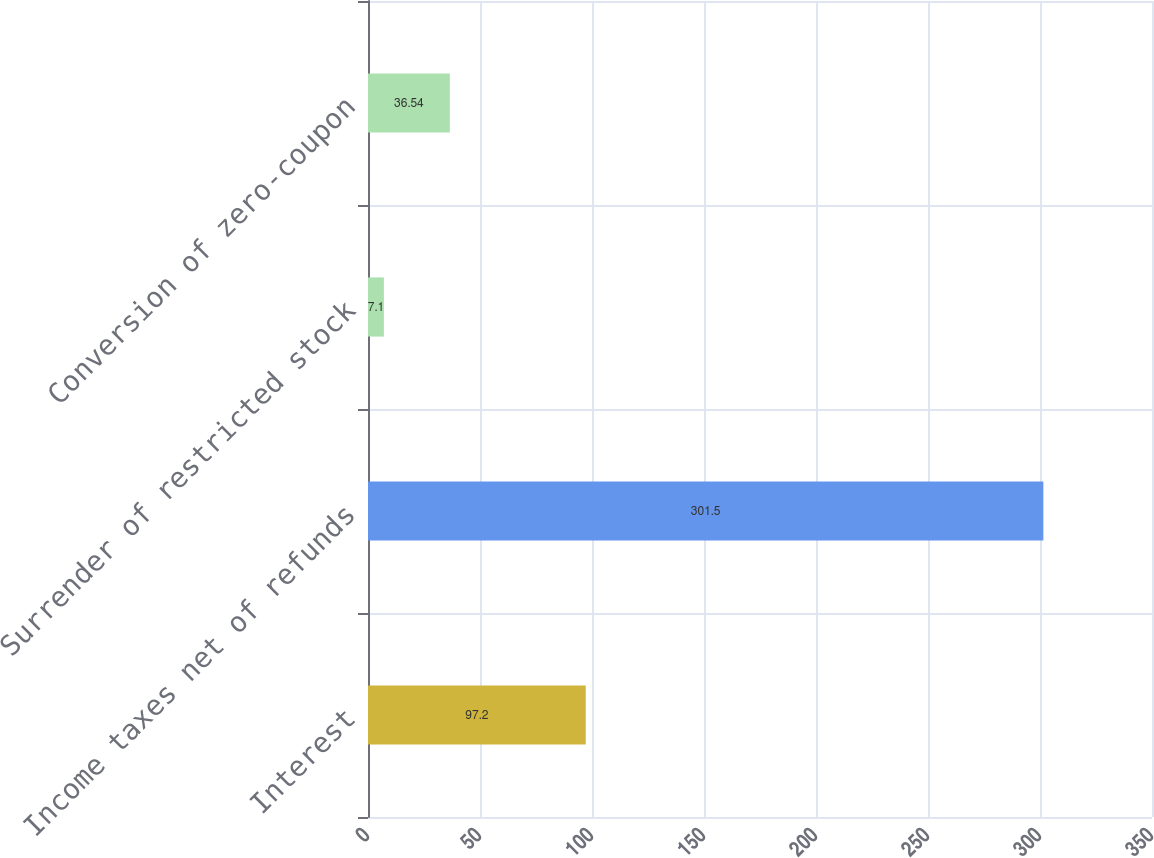Convert chart to OTSL. <chart><loc_0><loc_0><loc_500><loc_500><bar_chart><fcel>Interest<fcel>Income taxes net of refunds<fcel>Surrender of restricted stock<fcel>Conversion of zero-coupon<nl><fcel>97.2<fcel>301.5<fcel>7.1<fcel>36.54<nl></chart> 